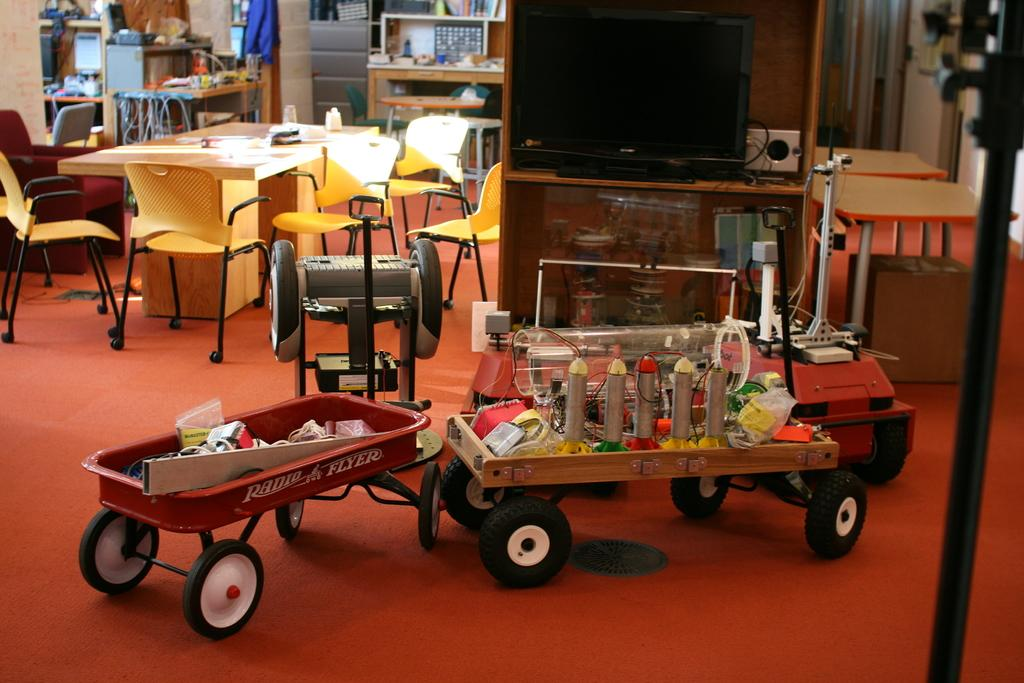What electronic device is visible at the top of the image? There is a television in the image, located at the top. What else can be seen in the middle of the image? There are toys in the image, located in the middle. What is on the toys? There is something on the toys, but the specifics are not mentioned in the facts. What type of furniture is present in the image? There are tables and chairs in the image. What items can be found on the tables? Papers and glasses are present on the tables. Can you tell me the account number of the zoo in the image? There is no mention of a zoo or an account number in the image or the provided facts. What type of pest is crawling on the television in the image? There is no pest visible on the television or any other part of the image. 